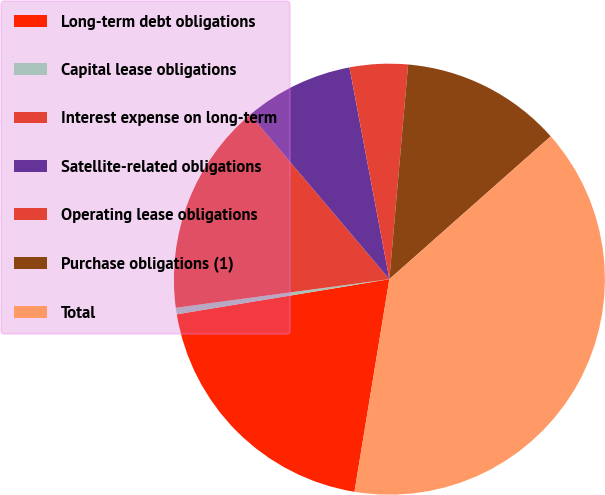<chart> <loc_0><loc_0><loc_500><loc_500><pie_chart><fcel>Long-term debt obligations<fcel>Capital lease obligations<fcel>Interest expense on long-term<fcel>Satellite-related obligations<fcel>Operating lease obligations<fcel>Purchase obligations (1)<fcel>Total<nl><fcel>19.8%<fcel>0.49%<fcel>15.94%<fcel>8.21%<fcel>4.35%<fcel>12.08%<fcel>39.12%<nl></chart> 